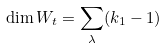<formula> <loc_0><loc_0><loc_500><loc_500>\dim W _ { t } = \sum _ { \lambda } ( k _ { 1 } - 1 )</formula> 